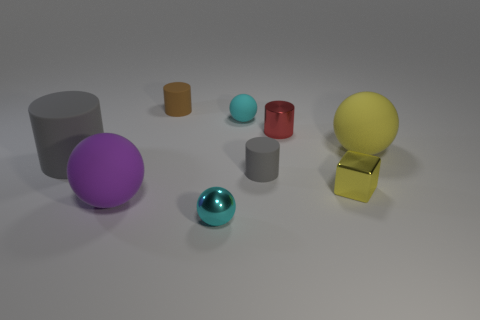Is the yellow rubber object the same size as the purple thing?
Your answer should be very brief. Yes. How many other objects are the same shape as the large yellow rubber thing?
Give a very brief answer. 3. Do the large gray matte thing and the purple rubber object have the same shape?
Provide a succinct answer. No. There is a small brown cylinder; are there any tiny things to the right of it?
Offer a terse response. Yes. What number of things are either big rubber things or cyan matte objects?
Keep it short and to the point. 4. How many other objects are there of the same size as the red cylinder?
Your answer should be compact. 5. How many rubber things are both on the left side of the big purple rubber sphere and on the right side of the big rubber cylinder?
Your answer should be very brief. 0. There is a rubber thing in front of the yellow metallic cube; is it the same size as the metal thing behind the large gray cylinder?
Provide a short and direct response. No. How big is the yellow thing that is behind the big gray matte thing?
Your answer should be compact. Large. What number of objects are either tiny cylinders that are in front of the small brown matte object or cyan balls in front of the tiny cyan matte ball?
Ensure brevity in your answer.  3. 